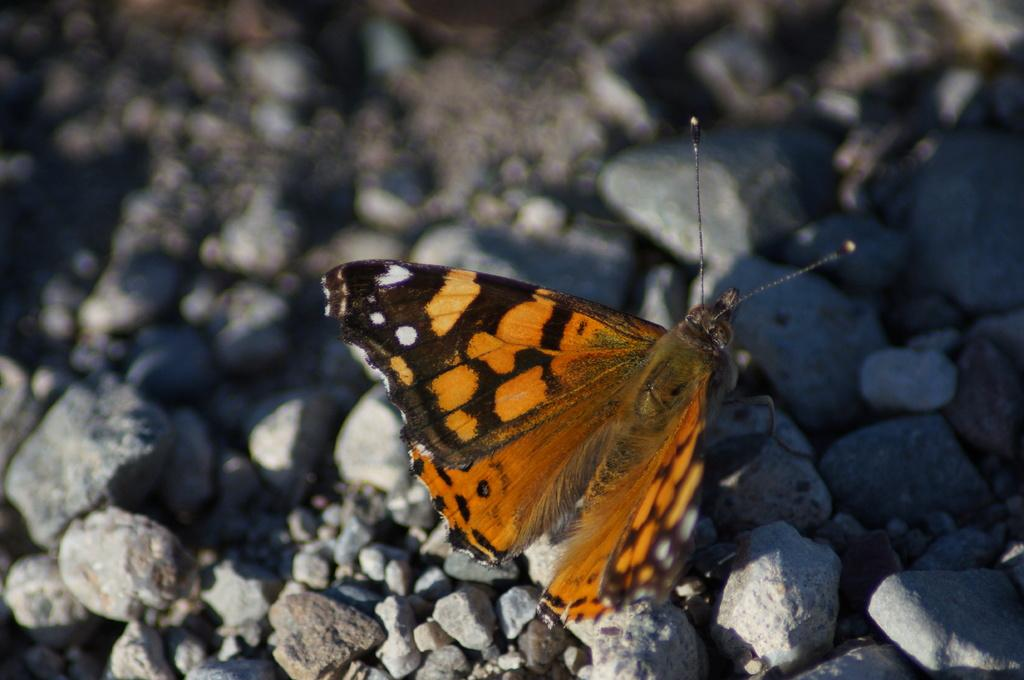What type of animal can be seen in the image? There is a butterfly in the image. What type of inanimate objects are present in the image? There are stones in the image. Is there any part of the image that appears blurred? Yes, there is a blurred part in the image. What type of metal is the butterfly made of in the image? The butterfly is not made of metal; it is a living creature. What symbol of peace can be seen in the image? There is no symbol of peace present in the image. 